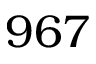<formula> <loc_0><loc_0><loc_500><loc_500>9 6 7</formula> 